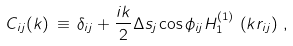Convert formula to latex. <formula><loc_0><loc_0><loc_500><loc_500>C _ { i j } ( k ) \, \equiv \, \delta _ { i j } + \frac { i k } { 2 } \Delta s _ { j } \cos \phi _ { i j } H _ { 1 } ^ { ( 1 ) } \, \left ( k r _ { i j } \right ) \, ,</formula> 